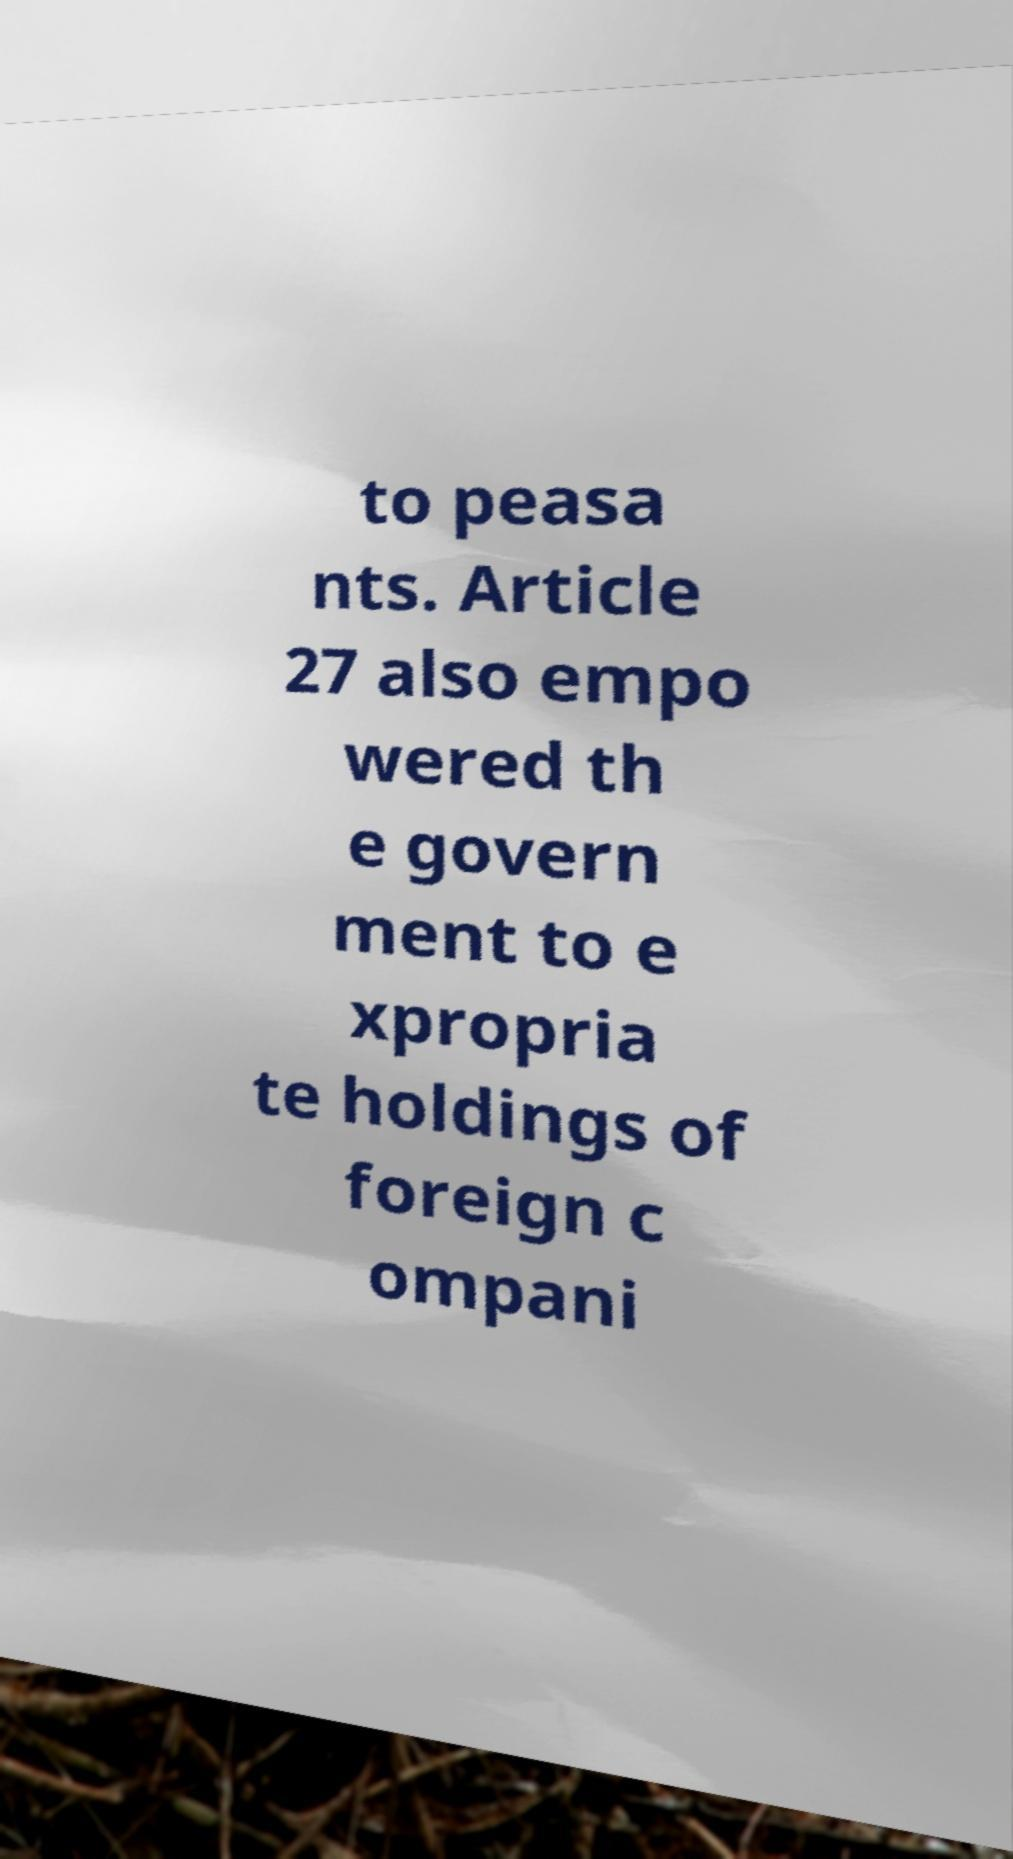Please identify and transcribe the text found in this image. to peasa nts. Article 27 also empo wered th e govern ment to e xpropria te holdings of foreign c ompani 